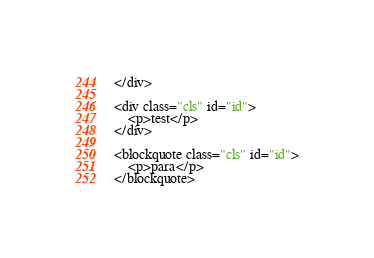<code> <loc_0><loc_0><loc_500><loc_500><_HTML_></div>

<div class="cls" id="id">
    <p>test</p>
</div>

<blockquote class="cls" id="id">
    <p>para</p>
</blockquote>
</code> 